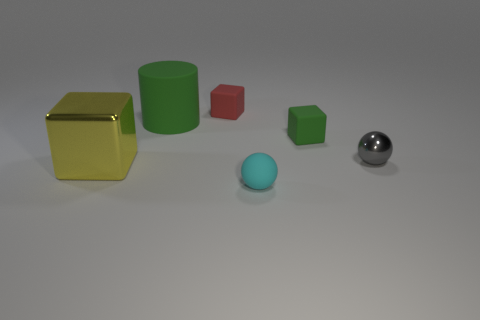Add 2 red cubes. How many objects exist? 8 Subtract all green matte cubes. How many cubes are left? 2 Subtract all purple blocks. How many red cylinders are left? 0 Subtract all cyan metallic blocks. Subtract all cubes. How many objects are left? 3 Add 6 small green objects. How many small green objects are left? 7 Add 5 big cyan shiny balls. How many big cyan shiny balls exist? 5 Subtract all red blocks. How many blocks are left? 2 Subtract 0 cyan cubes. How many objects are left? 6 Subtract all spheres. How many objects are left? 4 Subtract 1 blocks. How many blocks are left? 2 